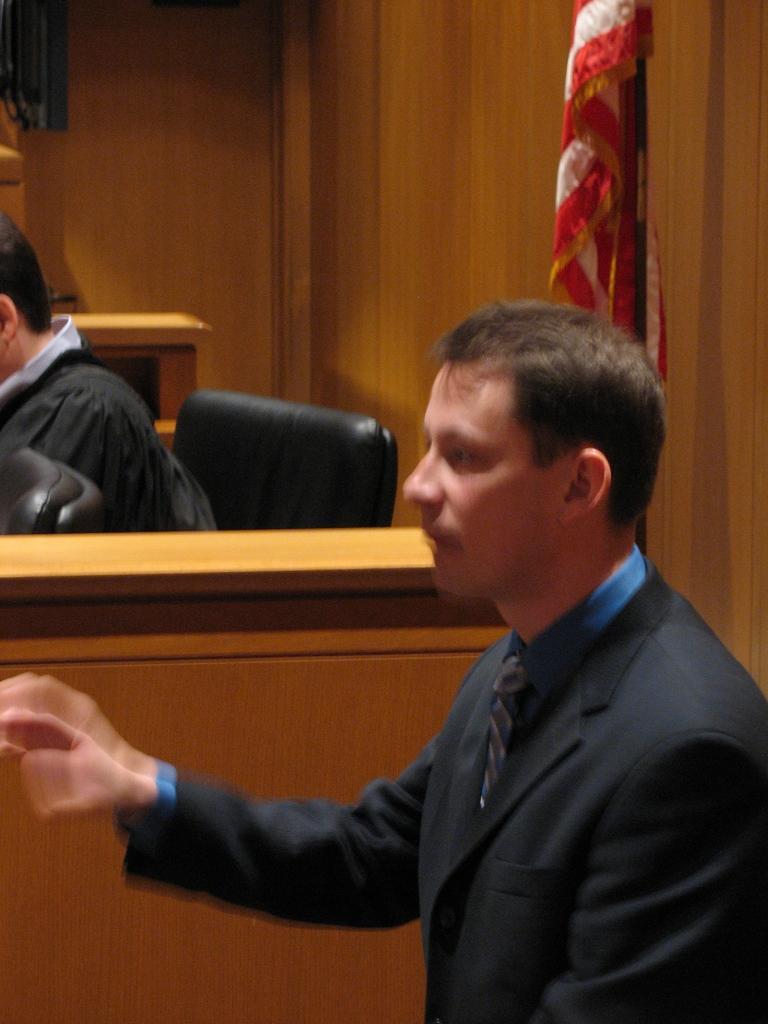Can you describe this image briefly? In this image, we can see a person and in the background, we can see a flag and there is an another person sitting on the chair. 